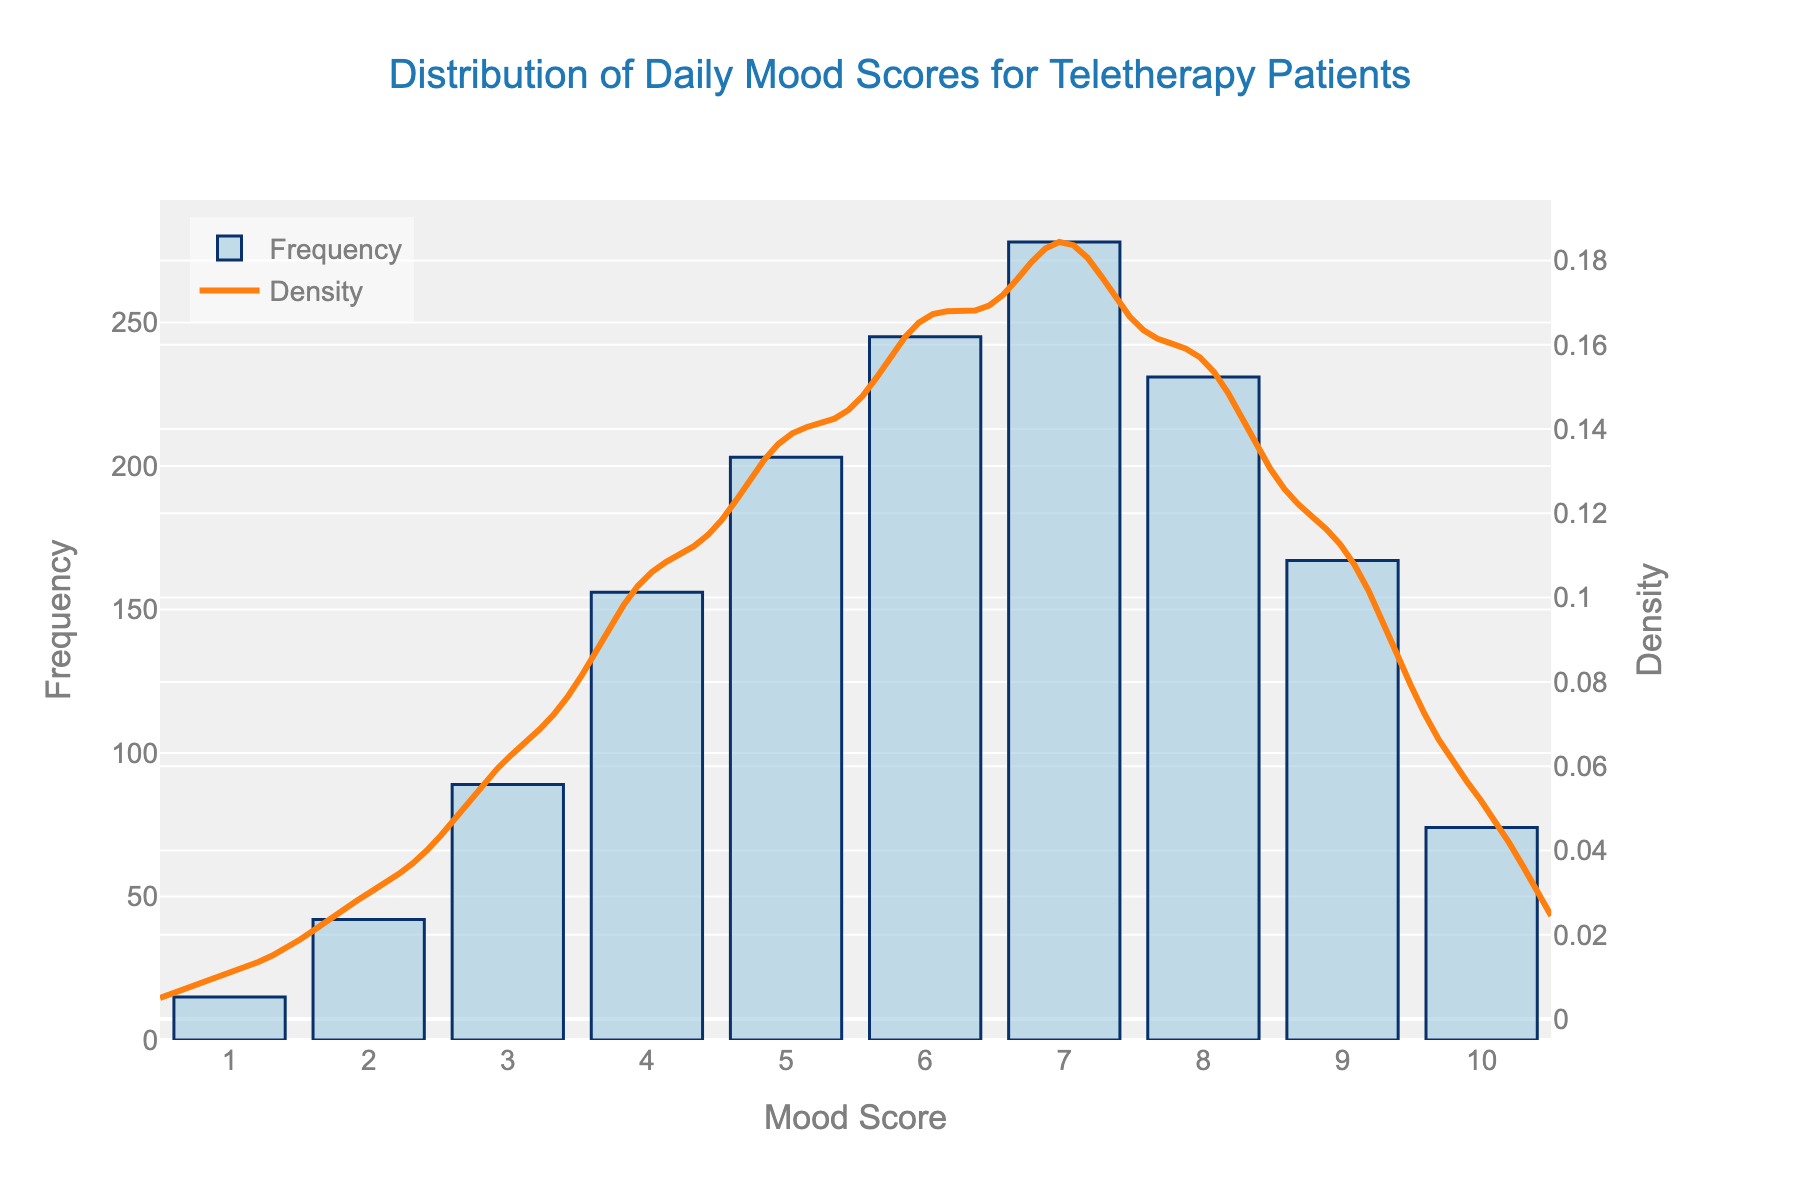What is the title of the figure? The title is usually prominently displayed at the top of the figure. It reads "Distribution of Daily Mood Scores for Teletherapy Patients."
Answer: Distribution of Daily Mood Scores for Teletherapy Patients What is the mood score with the highest frequency? The tallest bar in the histogram indicates the highest frequency. The bar for the mood score 7 is the tallest.
Answer: 7 How does the frequency of mood score 6 compare to that of mood score 9? To compare, look at the heights of the bars for mood scores 6 and 9. The bar for mood score 6 is taller than the bar for mood score 9.
Answer: Mood score 6 has a higher frequency What is the density peak value in the KDE curve? Identify the highest point on the density curve. The peak approximately occurs at mood score 7, around 0.075 in density.
Answer: Around 0.075 How does the frequency distribution of mood scores change as the score increases from 1 to 10? Initially, the frequency increases, peaks around mood scores 6 and 7, and then gradually decreases.
Answer: Increases, peaks around 6-7, then decreases Which mood scores have frequencies greater than 200? Look for bars that reach above the frequency line of 200. The mood scores 6, 7, and 8 have frequencies greater than 200.
Answer: 6, 7, and 8 What is the total frequency of mood scores in the histogram? Add up the frequencies for each mood score: 15 + 42 + 89 + 156 + 203 + 245 + 278 + 231 + 167 + 74 = 1500.
Answer: 1500 What is the range of mood scores that have the highest density in the KDE curve? The KDE curve peaks between mood scores 6 and 8.
Answer: Between 6 and 8 How many mood scores have a frequency less than 100? Count the bars with heights below 100. Mood scores 1, 2, 3, and 10 have frequencies less than 100.
Answer: 4 What can you infer about the overall mood distribution from the histogram and density curve? The histogram shows most patients have mood scores between 5 and 8, with the KDE curve peaking around these scores indicating the majority's mood levels are in this range.
Answer: Most patients' mood scores range between 5 and 8 